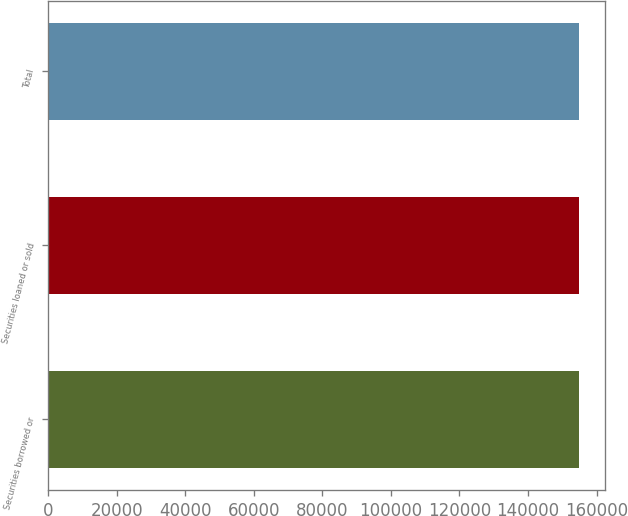<chart> <loc_0><loc_0><loc_500><loc_500><bar_chart><fcel>Securities borrowed or<fcel>Securities loaned or sold<fcel>Total<nl><fcel>154799<fcel>154799<fcel>154799<nl></chart> 